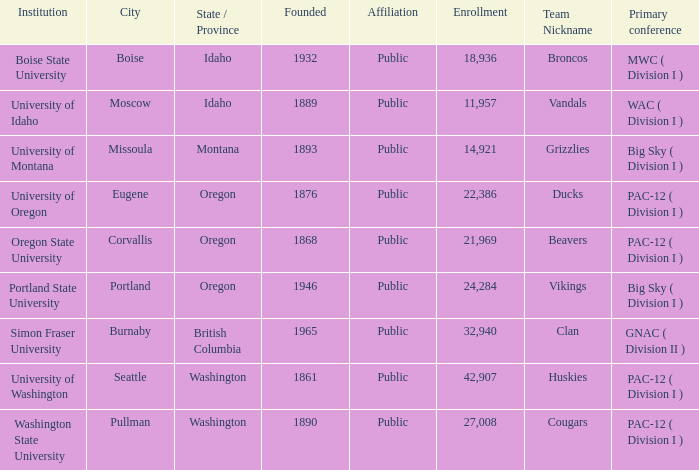What is the location of the University of Montana, which was founded after 1890? Missoula, Montana. 